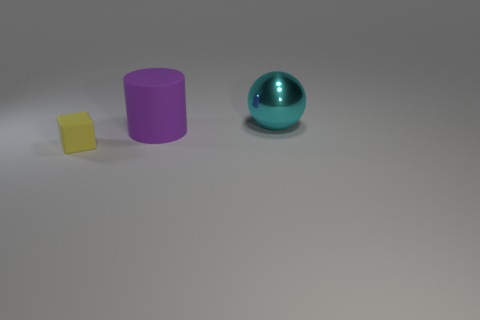What might be the context or purpose of these objects placed together? The arrangement of the objects, which represent basic geometric shapes, suggests a controlled environment perhaps used for an educational or demonstrative purpose, like teaching about geometry, color, or lighting in photography. 